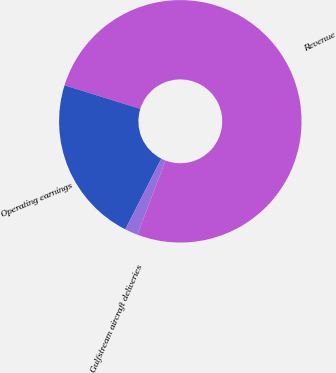Convert chart to OTSL. <chart><loc_0><loc_0><loc_500><loc_500><pie_chart><fcel>Revenue<fcel>Operating earnings<fcel>Gulfstream aircraft deliveries<nl><fcel>75.96%<fcel>22.31%<fcel>1.73%<nl></chart> 